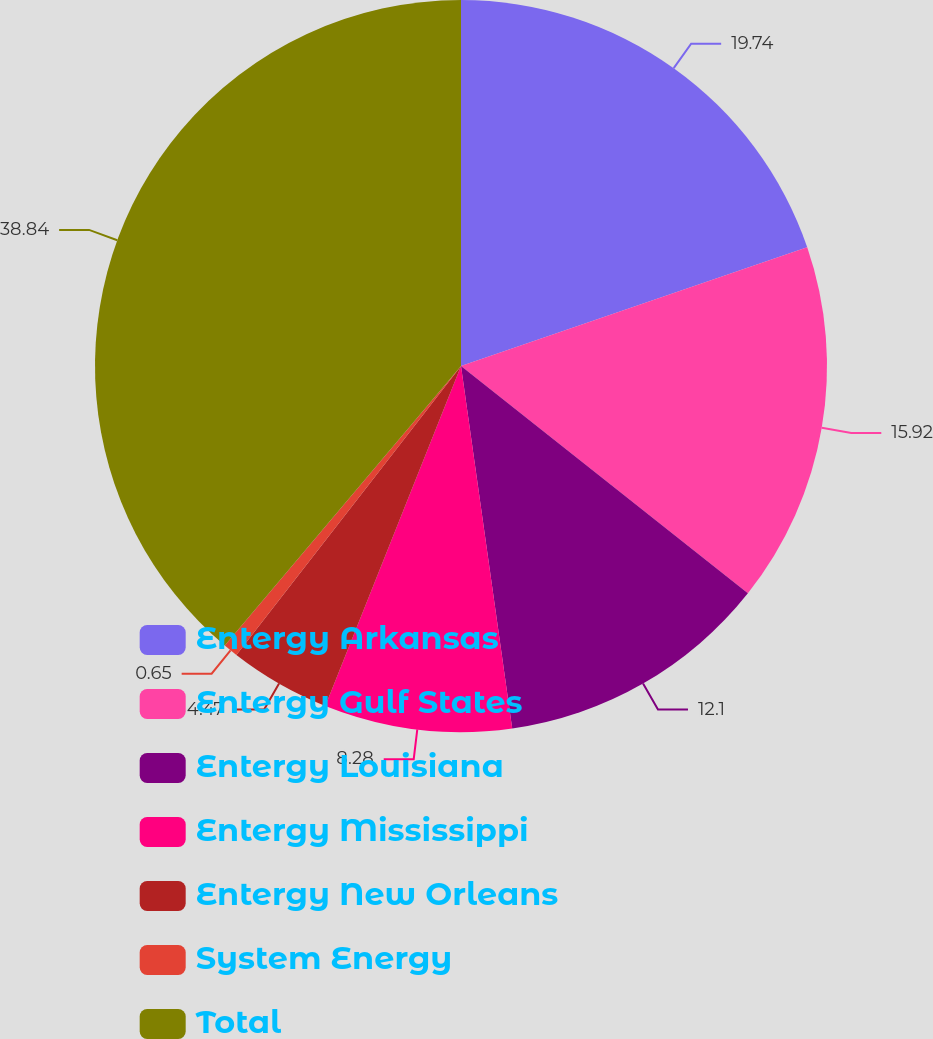<chart> <loc_0><loc_0><loc_500><loc_500><pie_chart><fcel>Entergy Arkansas<fcel>Entergy Gulf States<fcel>Entergy Louisiana<fcel>Entergy Mississippi<fcel>Entergy New Orleans<fcel>System Energy<fcel>Total<nl><fcel>19.74%<fcel>15.92%<fcel>12.1%<fcel>8.28%<fcel>4.47%<fcel>0.65%<fcel>38.83%<nl></chart> 